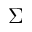<formula> <loc_0><loc_0><loc_500><loc_500>\Sigma</formula> 